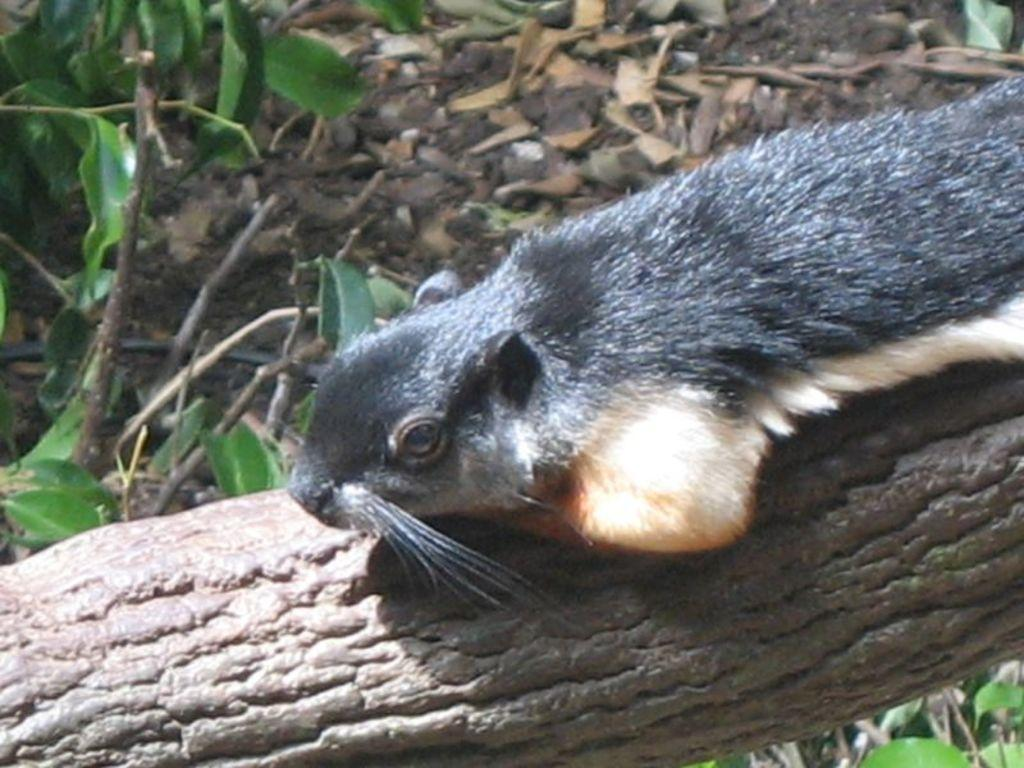What type of creature is in the picture? There is an animal in the picture. What colors can be seen on the animal? The animal is black and white in color. Where is the animal located in the picture? The animal is on tree bark. What other natural elements can be seen in the picture? Leaves are visible in the picture. How does the animal sort the leaves in the picture? The animal does not sort the leaves in the picture; it is simply sitting on the tree bark. What type of watch is the animal wearing in the picture? There is no watch visible on the animal in the picture. 